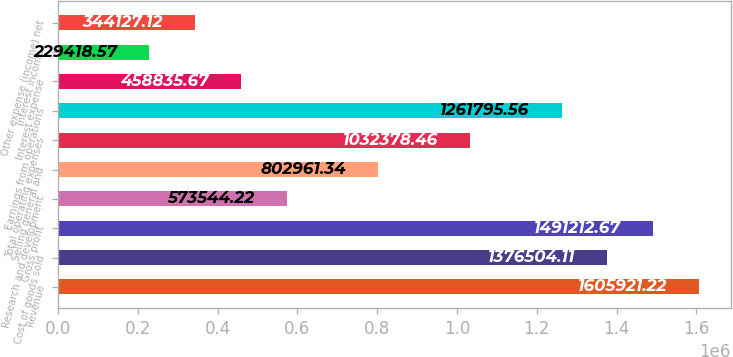Convert chart to OTSL. <chart><loc_0><loc_0><loc_500><loc_500><bar_chart><fcel>Revenue<fcel>Cost of goods sold<fcel>Gross profit<fcel>Research and development<fcel>Selling general and<fcel>Total operating expenses<fcel>Earnings from operations<fcel>Interest expense<fcel>Interest income<fcel>Other expense (income) net<nl><fcel>1.60592e+06<fcel>1.3765e+06<fcel>1.49121e+06<fcel>573544<fcel>802961<fcel>1.03238e+06<fcel>1.2618e+06<fcel>458836<fcel>229419<fcel>344127<nl></chart> 